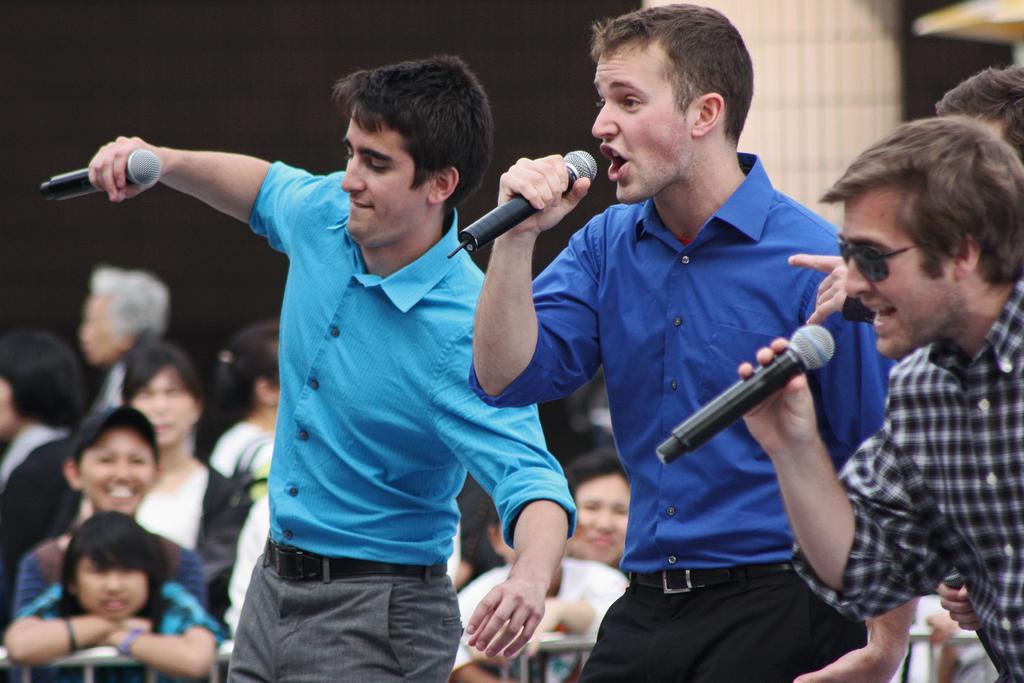Please provide a concise description of this image. In this image i can see few people standing and holding microphone in their hands. In the background i can see few people standing and watching the show. 